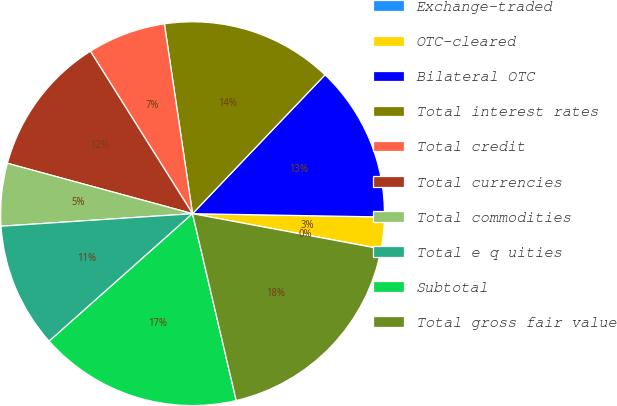<chart> <loc_0><loc_0><loc_500><loc_500><pie_chart><fcel>Exchange-traded<fcel>OTC-cleared<fcel>Bilateral OTC<fcel>Total interest rates<fcel>Total credit<fcel>Total currencies<fcel>Total commodities<fcel>Total e q uities<fcel>Subtotal<fcel>Total gross fair value<nl><fcel>0.02%<fcel>2.65%<fcel>13.15%<fcel>14.47%<fcel>6.59%<fcel>11.84%<fcel>5.27%<fcel>10.53%<fcel>17.09%<fcel>18.4%<nl></chart> 